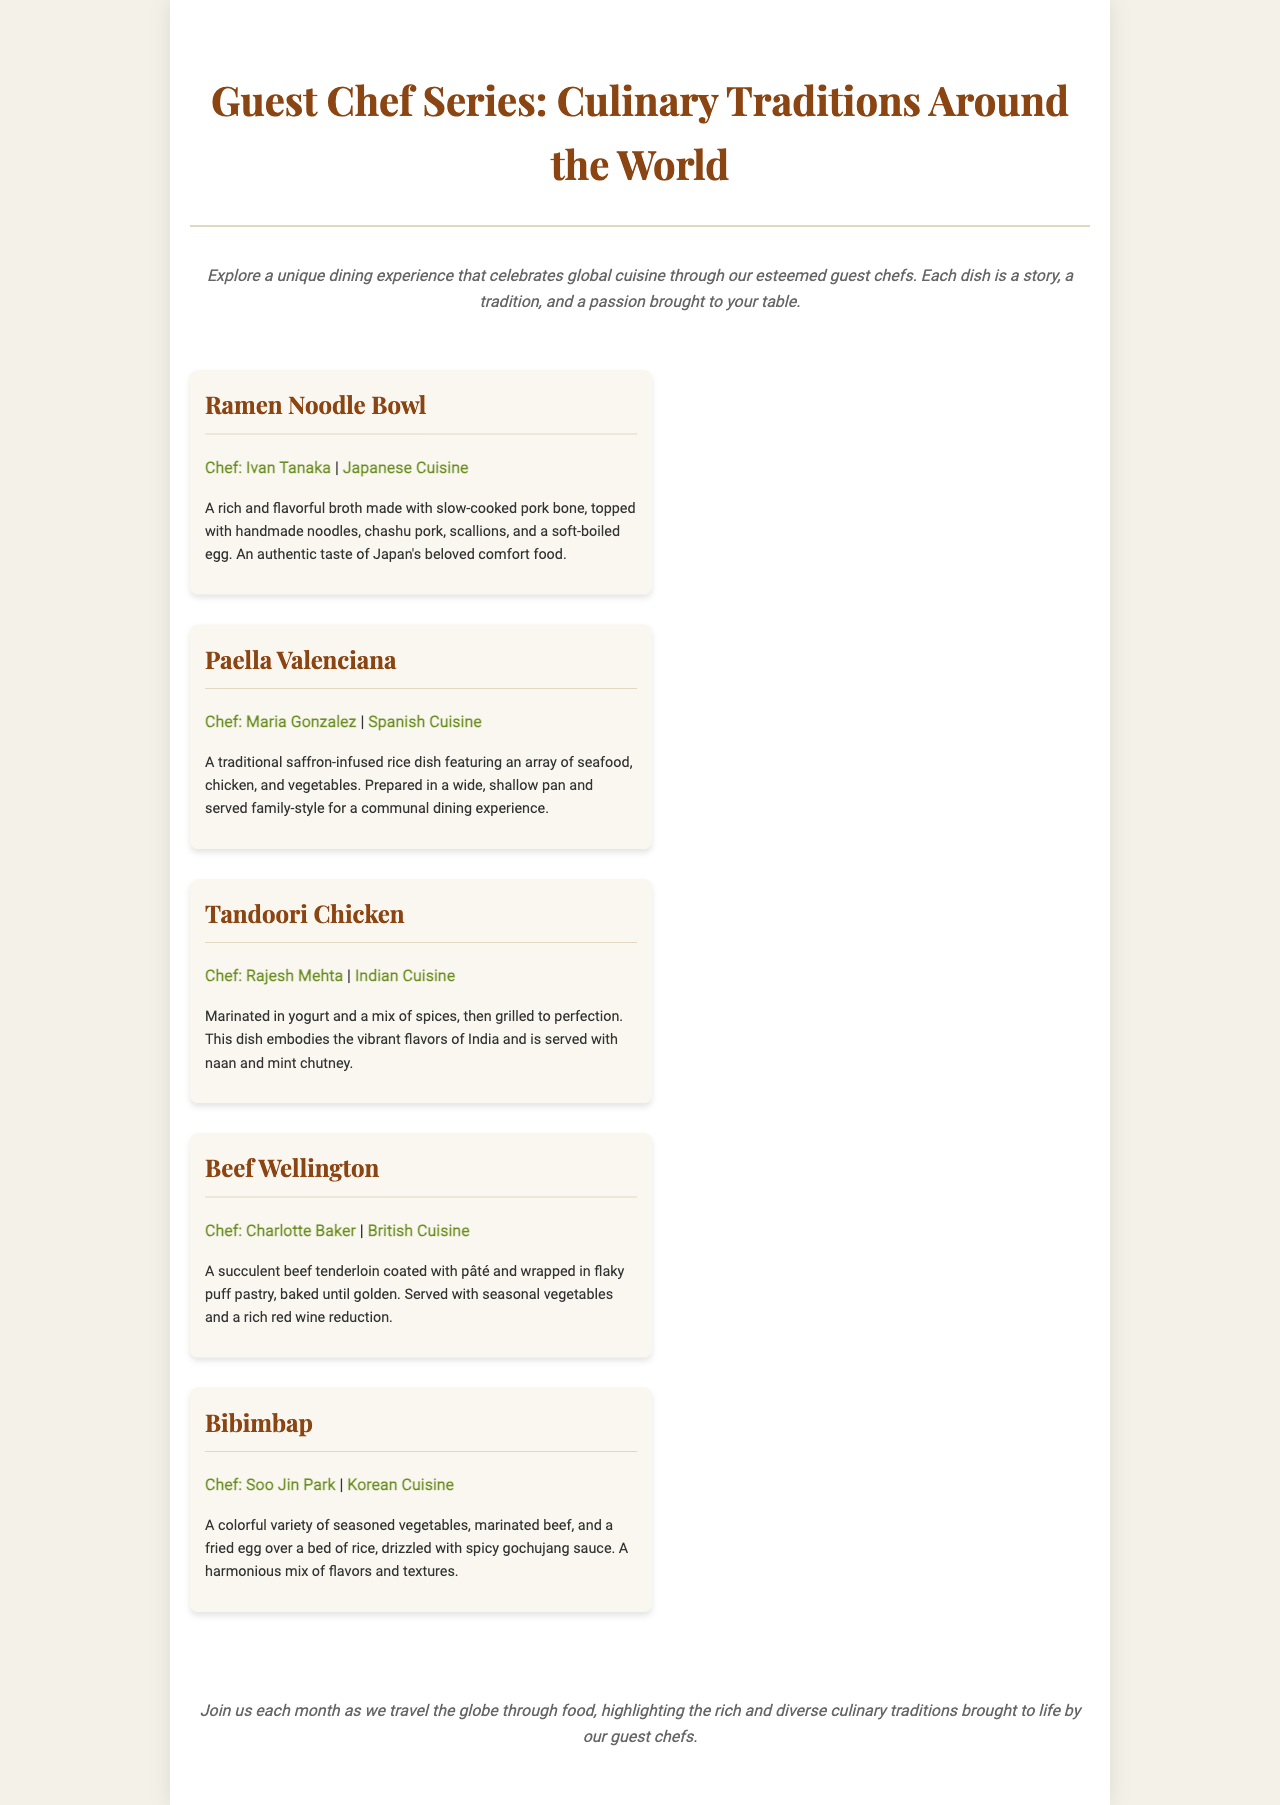what is the title of the document? The title of the document is presented at the top of the page.
Answer: Guest Chef Series: Culinary Traditions Around the World how many dishes are featured in the menu? The document lists five dishes under the menu section.
Answer: 5 who is the chef for the Ramen Noodle Bowl? The information about the chef for each dish is included in the respective dish description.
Answer: Ivan Tanaka which cuisine is associated with Tandoori Chicken? Each dish includes a section about its associated culinary tradition.
Answer: Indian Cuisine what is the main ingredient of the Beef Wellington? The description of Beef Wellington mentions its key component in the preparation.
Answer: Beef tenderloin which dish includes a fried egg? This detail can be found in the description of a specific dish that mentions a fried egg.
Answer: Bibimbap what type of dining experience does the Paella Valenciana offer? The description explains how the dish is served and enjoyed.
Answer: Communal dining experience what is the main flavoring ingredient in Bibimbap? The description of Bibimbap specifies a key condiment used in the dish.
Answer: Gochujang sauce 